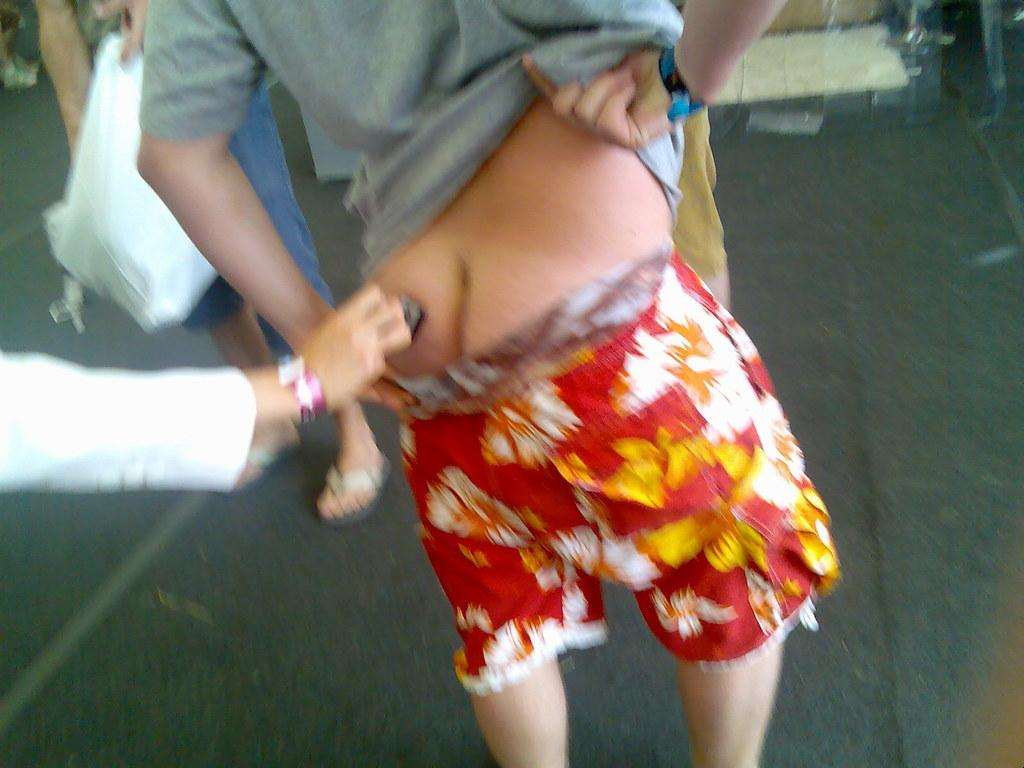What is the person in the image doing? The person is standing in the image. What is the person wearing on their upper body? The person is wearing a grey t-shirt. What is the person wearing on their lower body? The person is wearing red shorts. What is happening to the standing person in the image? Another person is stamping on the standing person's bum. Is there any blood visible in the image due to the stamping? There is no mention of blood in the image, and it cannot be determined from the provided facts. 